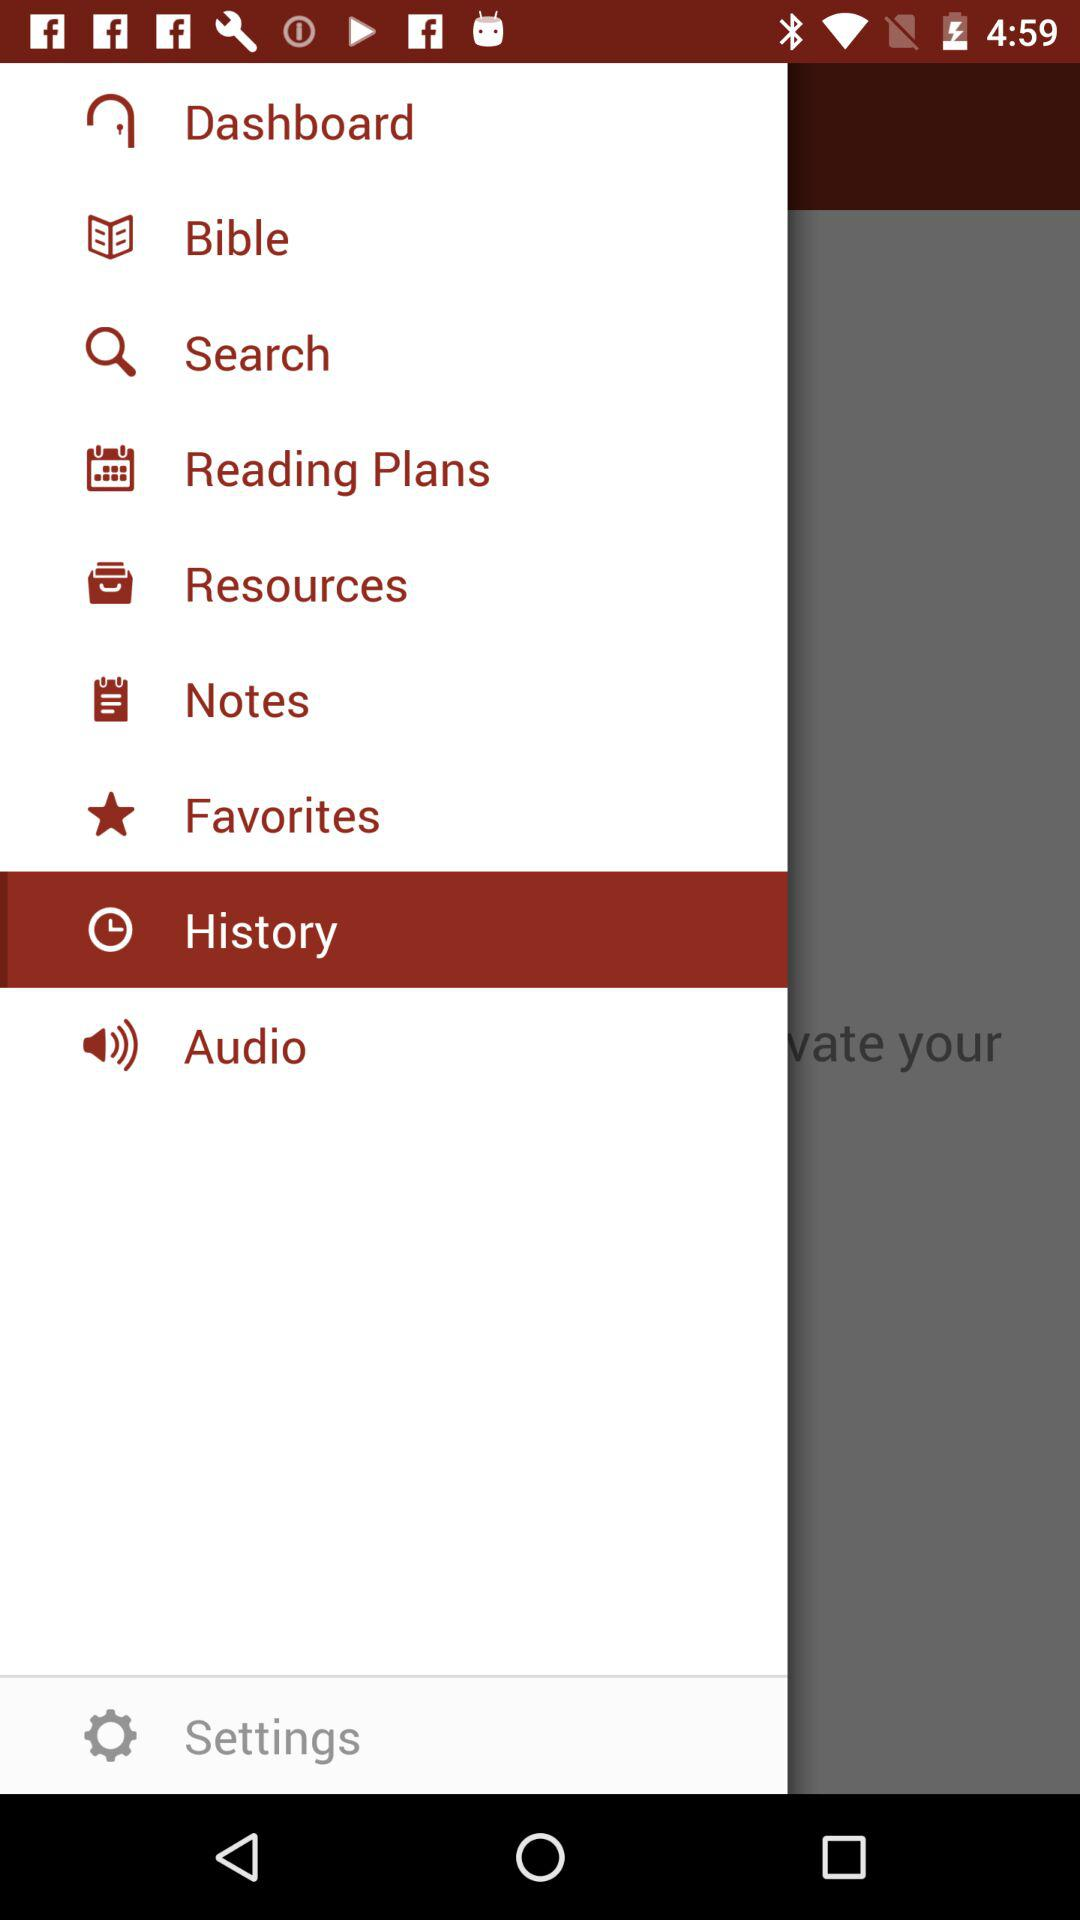What is the selected item? The selected item is "History". 